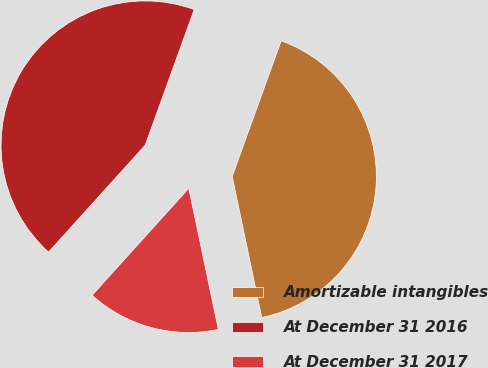Convert chart to OTSL. <chart><loc_0><loc_0><loc_500><loc_500><pie_chart><fcel>Amortizable intangibles<fcel>At December 31 2016<fcel>At December 31 2017<nl><fcel>41.2%<fcel>43.82%<fcel>14.98%<nl></chart> 